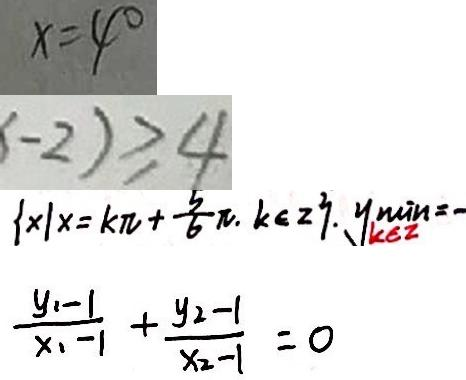<formula> <loc_0><loc_0><loc_500><loc_500>x = 4 ^ { \circ } 
 - 2 ) \geq 4 
 \{ x \vert x = k \pi + \frac { 5 } { 6 } \pi . k \in z \} . y ^ { \mu i n } _ { k \in z } = - 
 \frac { y _ { 2 } - 1 } { x _ { 1 } - 1 } + \frac { y _ { 2 } - 1 } { x _ { 2 } - 1 } = 0</formula> 